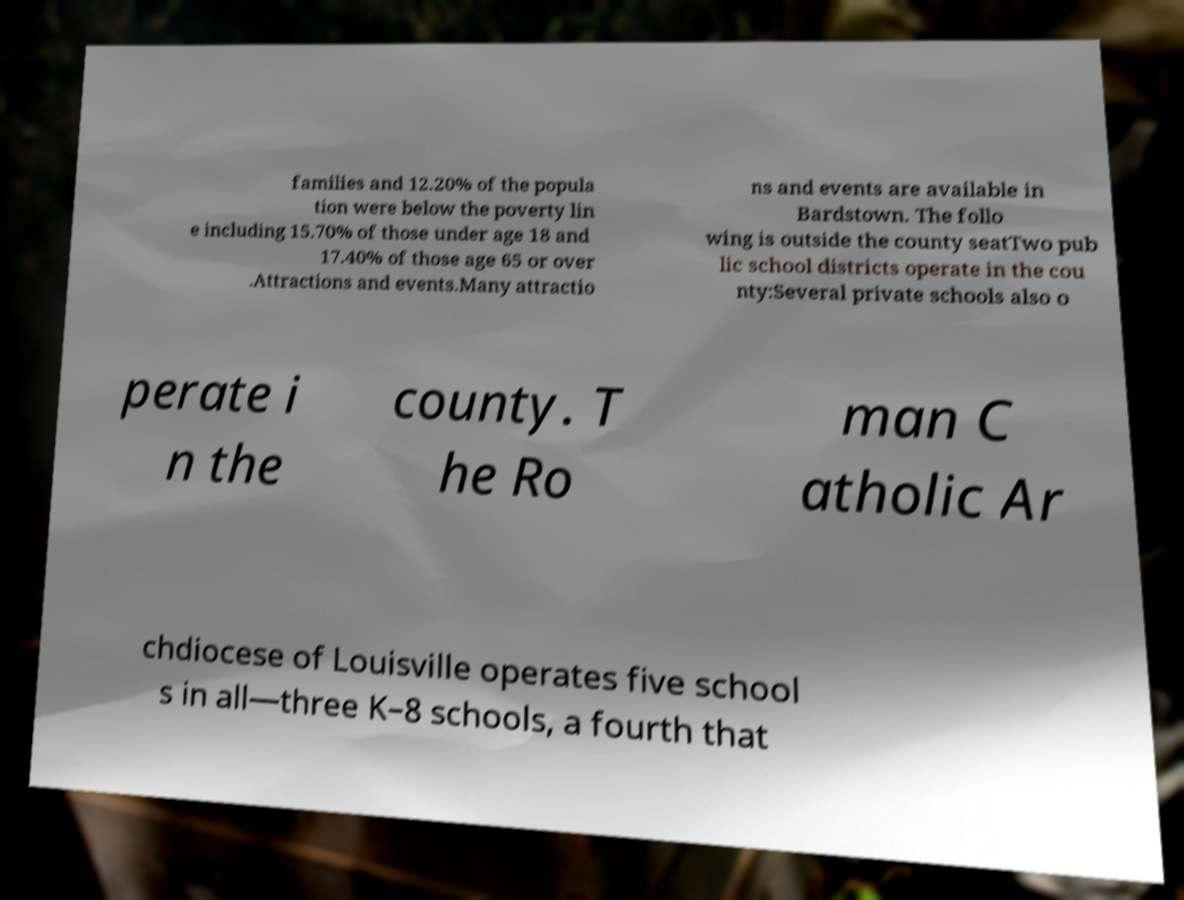Can you read and provide the text displayed in the image?This photo seems to have some interesting text. Can you extract and type it out for me? families and 12.20% of the popula tion were below the poverty lin e including 15.70% of those under age 18 and 17.40% of those age 65 or over .Attractions and events.Many attractio ns and events are available in Bardstown. The follo wing is outside the county seatTwo pub lic school districts operate in the cou nty:Several private schools also o perate i n the county. T he Ro man C atholic Ar chdiocese of Louisville operates five school s in all—three K–8 schools, a fourth that 